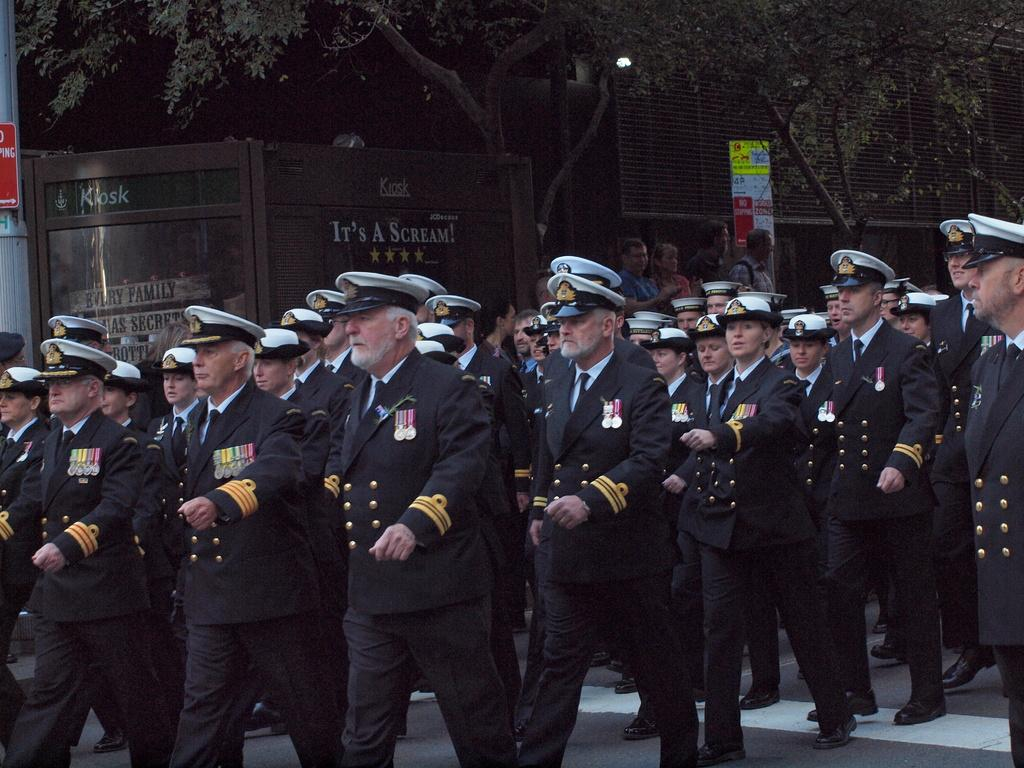Who or what can be seen in the image? There are people in the image. What are the people doing in the image? The people are marching on the road. What are the people wearing in the image? They are wearing black coats and white caps on their heads. What can be seen in the background of the image? There are trees in the background of the image. What type of drink is being offered to the chickens in the image? There are no chickens or drinks present in the image. 